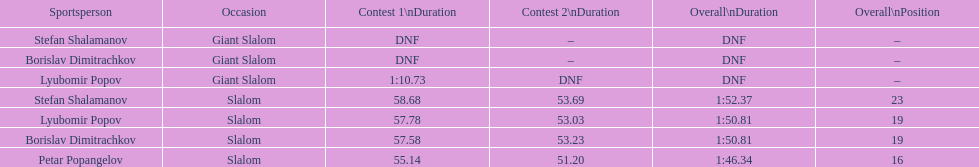What is the rank number of stefan shalamanov in the slalom event 23. 